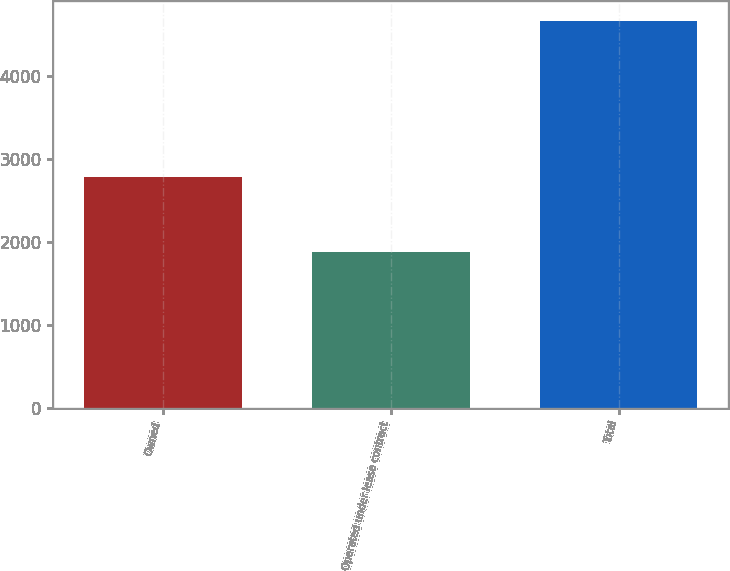Convert chart. <chart><loc_0><loc_0><loc_500><loc_500><bar_chart><fcel>Owned<fcel>Operated under lease contract<fcel>Total<nl><fcel>2780<fcel>1881<fcel>4661<nl></chart> 